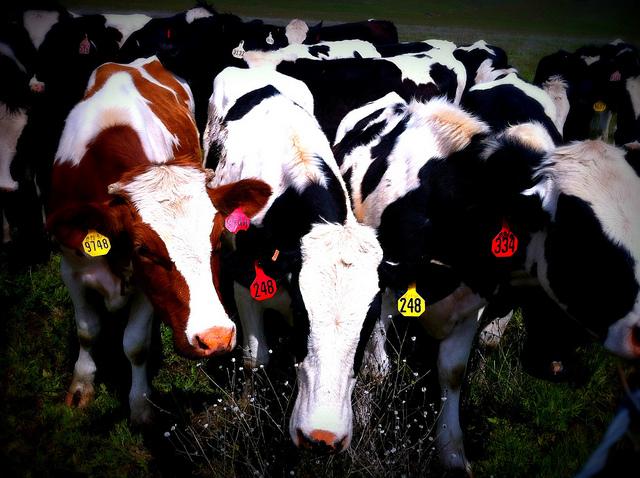What is under the cow in the middle?
Short answer required. Plant. How many tags do you see?
Answer briefly. 5. How many different colors of tags are there?
Write a very short answer. 2. 